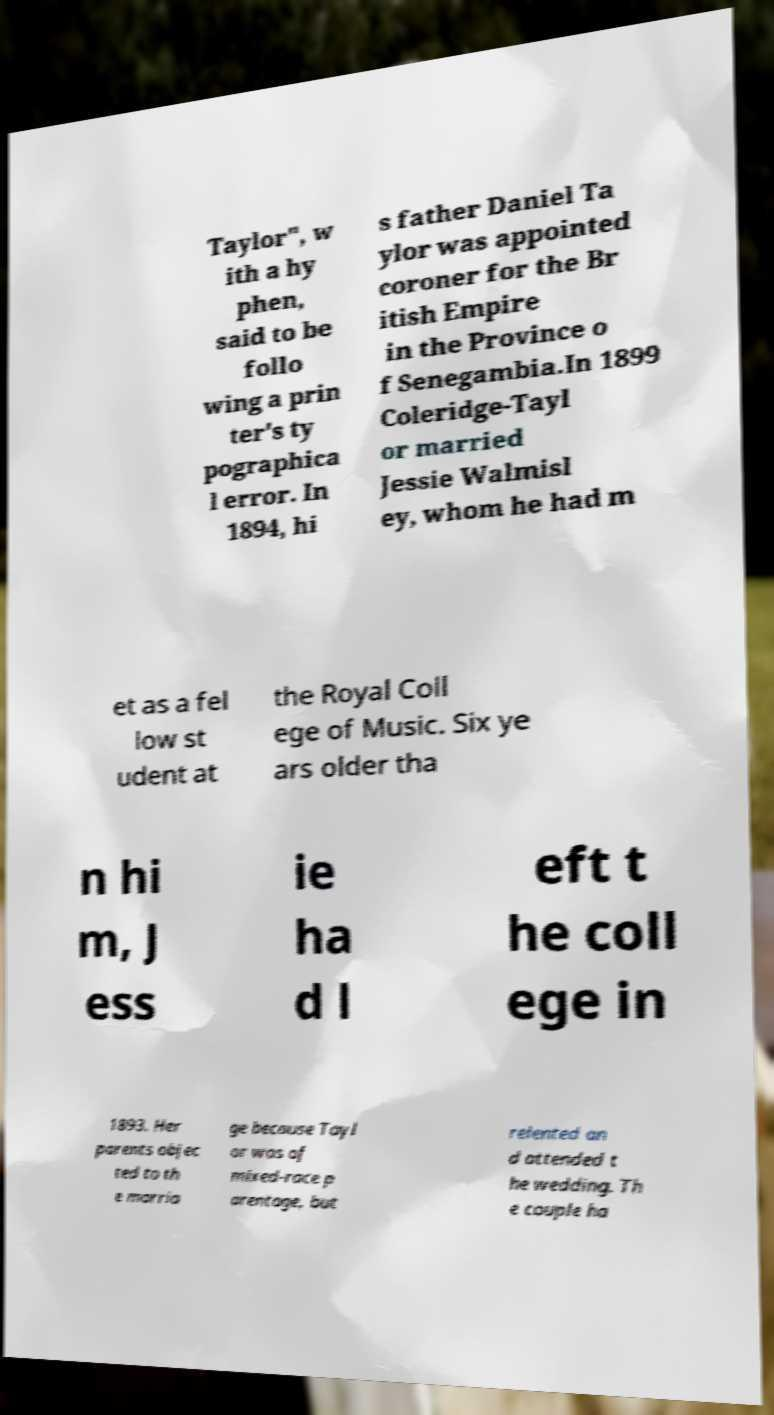What messages or text are displayed in this image? I need them in a readable, typed format. Taylor", w ith a hy phen, said to be follo wing a prin ter's ty pographica l error. In 1894, hi s father Daniel Ta ylor was appointed coroner for the Br itish Empire in the Province o f Senegambia.In 1899 Coleridge-Tayl or married Jessie Walmisl ey, whom he had m et as a fel low st udent at the Royal Coll ege of Music. Six ye ars older tha n hi m, J ess ie ha d l eft t he coll ege in 1893. Her parents objec ted to th e marria ge because Tayl or was of mixed-race p arentage, but relented an d attended t he wedding. Th e couple ha 